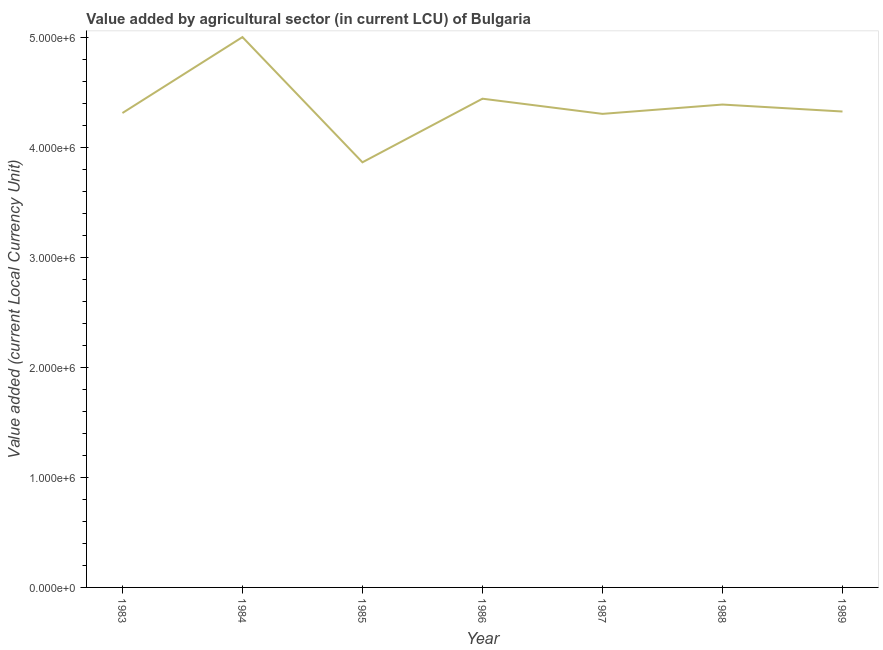What is the value added by agriculture sector in 1987?
Provide a short and direct response. 4.31e+06. Across all years, what is the maximum value added by agriculture sector?
Ensure brevity in your answer.  5.01e+06. Across all years, what is the minimum value added by agriculture sector?
Offer a terse response. 3.87e+06. What is the sum of the value added by agriculture sector?
Keep it short and to the point. 3.07e+07. What is the difference between the value added by agriculture sector in 1983 and 1987?
Ensure brevity in your answer.  7700. What is the average value added by agriculture sector per year?
Your answer should be compact. 4.38e+06. What is the median value added by agriculture sector?
Your answer should be very brief. 4.33e+06. What is the ratio of the value added by agriculture sector in 1985 to that in 1987?
Give a very brief answer. 0.9. Is the value added by agriculture sector in 1986 less than that in 1987?
Keep it short and to the point. No. Is the difference between the value added by agriculture sector in 1984 and 1987 greater than the difference between any two years?
Offer a very short reply. No. What is the difference between the highest and the second highest value added by agriculture sector?
Provide a short and direct response. 5.61e+05. What is the difference between the highest and the lowest value added by agriculture sector?
Ensure brevity in your answer.  1.14e+06. In how many years, is the value added by agriculture sector greater than the average value added by agriculture sector taken over all years?
Ensure brevity in your answer.  3. What is the difference between two consecutive major ticks on the Y-axis?
Provide a short and direct response. 1.00e+06. Are the values on the major ticks of Y-axis written in scientific E-notation?
Give a very brief answer. Yes. Does the graph contain any zero values?
Give a very brief answer. No. What is the title of the graph?
Provide a short and direct response. Value added by agricultural sector (in current LCU) of Bulgaria. What is the label or title of the Y-axis?
Offer a very short reply. Value added (current Local Currency Unit). What is the Value added (current Local Currency Unit) in 1983?
Provide a succinct answer. 4.32e+06. What is the Value added (current Local Currency Unit) in 1984?
Offer a terse response. 5.01e+06. What is the Value added (current Local Currency Unit) of 1985?
Provide a short and direct response. 3.87e+06. What is the Value added (current Local Currency Unit) of 1986?
Make the answer very short. 4.45e+06. What is the Value added (current Local Currency Unit) of 1987?
Offer a terse response. 4.31e+06. What is the Value added (current Local Currency Unit) in 1988?
Ensure brevity in your answer.  4.39e+06. What is the Value added (current Local Currency Unit) of 1989?
Provide a succinct answer. 4.33e+06. What is the difference between the Value added (current Local Currency Unit) in 1983 and 1984?
Make the answer very short. -6.91e+05. What is the difference between the Value added (current Local Currency Unit) in 1983 and 1985?
Ensure brevity in your answer.  4.48e+05. What is the difference between the Value added (current Local Currency Unit) in 1983 and 1986?
Keep it short and to the point. -1.30e+05. What is the difference between the Value added (current Local Currency Unit) in 1983 and 1987?
Your answer should be compact. 7700. What is the difference between the Value added (current Local Currency Unit) in 1983 and 1988?
Provide a succinct answer. -7.71e+04. What is the difference between the Value added (current Local Currency Unit) in 1983 and 1989?
Make the answer very short. -1.37e+04. What is the difference between the Value added (current Local Currency Unit) in 1984 and 1985?
Keep it short and to the point. 1.14e+06. What is the difference between the Value added (current Local Currency Unit) in 1984 and 1986?
Your answer should be compact. 5.61e+05. What is the difference between the Value added (current Local Currency Unit) in 1984 and 1987?
Provide a succinct answer. 6.99e+05. What is the difference between the Value added (current Local Currency Unit) in 1984 and 1988?
Ensure brevity in your answer.  6.14e+05. What is the difference between the Value added (current Local Currency Unit) in 1984 and 1989?
Your answer should be compact. 6.77e+05. What is the difference between the Value added (current Local Currency Unit) in 1985 and 1986?
Your response must be concise. -5.79e+05. What is the difference between the Value added (current Local Currency Unit) in 1985 and 1987?
Offer a terse response. -4.41e+05. What is the difference between the Value added (current Local Currency Unit) in 1985 and 1988?
Keep it short and to the point. -5.26e+05. What is the difference between the Value added (current Local Currency Unit) in 1985 and 1989?
Make the answer very short. -4.62e+05. What is the difference between the Value added (current Local Currency Unit) in 1986 and 1987?
Give a very brief answer. 1.38e+05. What is the difference between the Value added (current Local Currency Unit) in 1986 and 1988?
Ensure brevity in your answer.  5.33e+04. What is the difference between the Value added (current Local Currency Unit) in 1986 and 1989?
Keep it short and to the point. 1.17e+05. What is the difference between the Value added (current Local Currency Unit) in 1987 and 1988?
Your response must be concise. -8.48e+04. What is the difference between the Value added (current Local Currency Unit) in 1987 and 1989?
Your response must be concise. -2.14e+04. What is the difference between the Value added (current Local Currency Unit) in 1988 and 1989?
Offer a terse response. 6.34e+04. What is the ratio of the Value added (current Local Currency Unit) in 1983 to that in 1984?
Make the answer very short. 0.86. What is the ratio of the Value added (current Local Currency Unit) in 1983 to that in 1985?
Offer a terse response. 1.12. What is the ratio of the Value added (current Local Currency Unit) in 1984 to that in 1985?
Provide a short and direct response. 1.29. What is the ratio of the Value added (current Local Currency Unit) in 1984 to that in 1986?
Offer a very short reply. 1.13. What is the ratio of the Value added (current Local Currency Unit) in 1984 to that in 1987?
Provide a succinct answer. 1.16. What is the ratio of the Value added (current Local Currency Unit) in 1984 to that in 1988?
Ensure brevity in your answer.  1.14. What is the ratio of the Value added (current Local Currency Unit) in 1984 to that in 1989?
Keep it short and to the point. 1.16. What is the ratio of the Value added (current Local Currency Unit) in 1985 to that in 1986?
Your answer should be very brief. 0.87. What is the ratio of the Value added (current Local Currency Unit) in 1985 to that in 1987?
Keep it short and to the point. 0.9. What is the ratio of the Value added (current Local Currency Unit) in 1985 to that in 1988?
Keep it short and to the point. 0.88. What is the ratio of the Value added (current Local Currency Unit) in 1985 to that in 1989?
Give a very brief answer. 0.89. What is the ratio of the Value added (current Local Currency Unit) in 1986 to that in 1987?
Ensure brevity in your answer.  1.03. What is the ratio of the Value added (current Local Currency Unit) in 1987 to that in 1989?
Give a very brief answer. 0.99. 